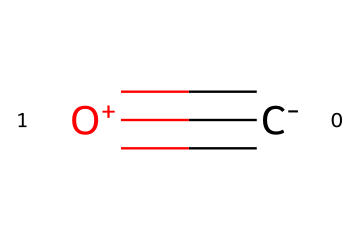What is the chemical name of this compound? The SMILES representation indicates one carbon atom and one oxygen atom connected by a triple bond. This structure corresponds to carbon monoxide.
Answer: carbon monoxide How many atoms are present in this molecule? Analyzing the SMILES structure, there is one carbon atom and one oxygen atom, totaling two atoms.
Answer: two How many bonds are in this molecular structure? The representation shows a triple bond between the carbon and oxygen atoms, which counts as one bond.
Answer: one What is the oxidation state of carbon in carbon monoxide? In carbon monoxide, carbon is typically at an oxidation state of +2, as the oxygen atom is more electronegative and pulls electrons away.
Answer: +2 Is carbon monoxide flammable? Yes, carbon monoxide is flammable and can ignite in the presence of a suitable ignition source.
Answer: yes What type of bond exists between carbon and oxygen in this molecule? The presence of '#', denoting a triple bond in the SMILES representation, indicates that there is a triple bond between carbon and oxygen.
Answer: triple bond Is carbon monoxide a toxic gas? Carbon monoxide is considered toxic as it can bind to hemoglobin in the blood, preventing oxygen transport.
Answer: toxic 